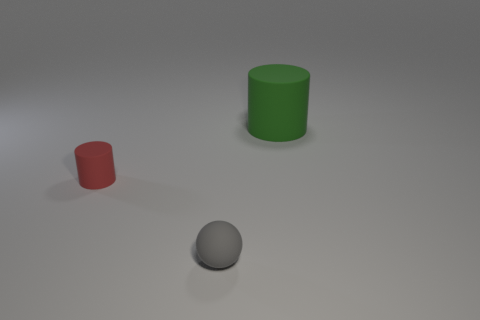Add 2 large cyan shiny objects. How many objects exist? 5 Subtract all cylinders. How many objects are left? 1 Subtract all large cylinders. Subtract all cylinders. How many objects are left? 0 Add 1 rubber cylinders. How many rubber cylinders are left? 3 Add 3 small purple matte balls. How many small purple matte balls exist? 3 Subtract 0 gray cylinders. How many objects are left? 3 